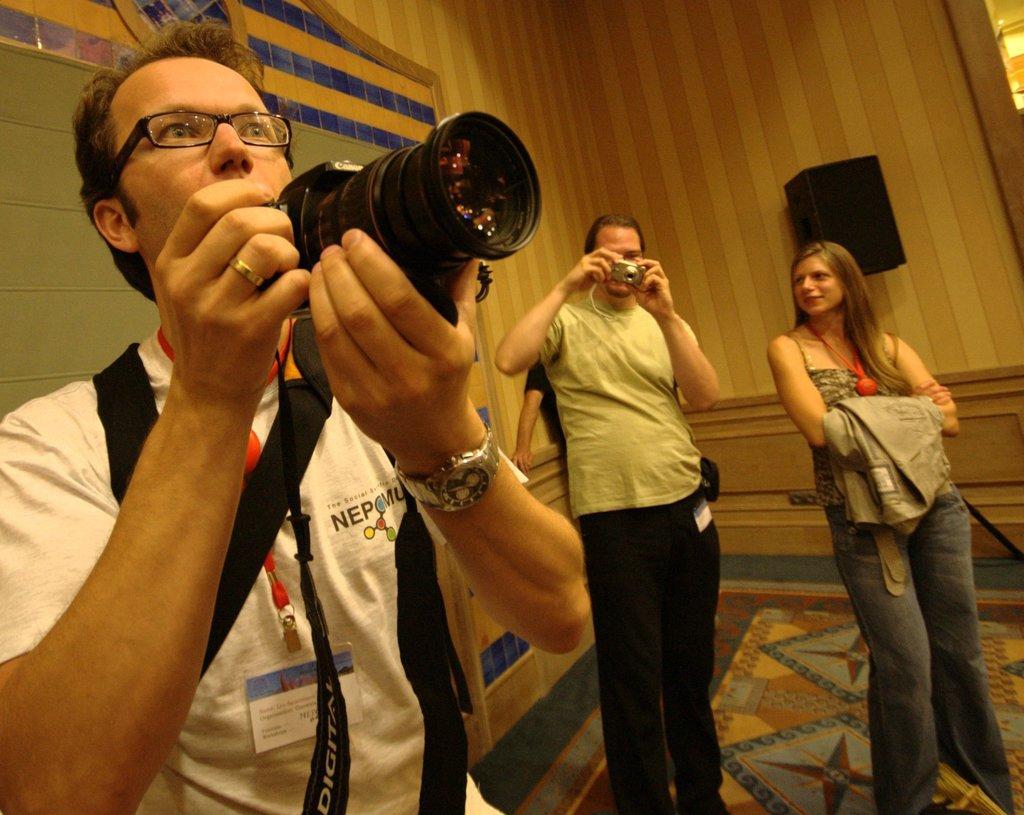Describe this image in one or two sentences. In the background we can see the wall. In this picture we can see the people standing. We can see few objects. On the right side of the picture we can see a man wearing a t-shirt, wrist watch, spectacles and he is holding a camera. In the middle we can see a person holding a camera. At the bottom portion of the picture we can see the floor. 